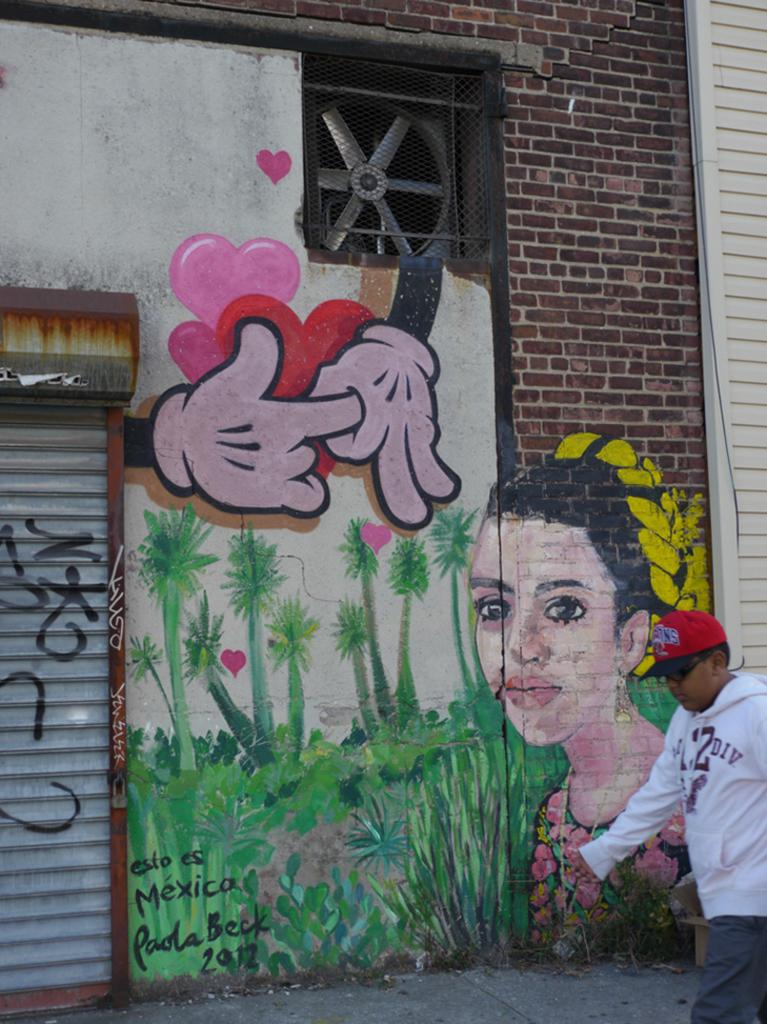What is the main subject of the image? There is a boy walking in the image. What can be seen on the wall in the image? There is a painting on the wall in the image. What type of window covering is present in the image? There is a shutter in the image. What type of barrier is visible in the image? There is a mesh in the image. What type of ventilation system is present in the image? There is an exhaust fan in the image. Can you see a pig in the image? No, there is no pig present in the image. What type of door is visible in the image? There is no door visible in the image. 